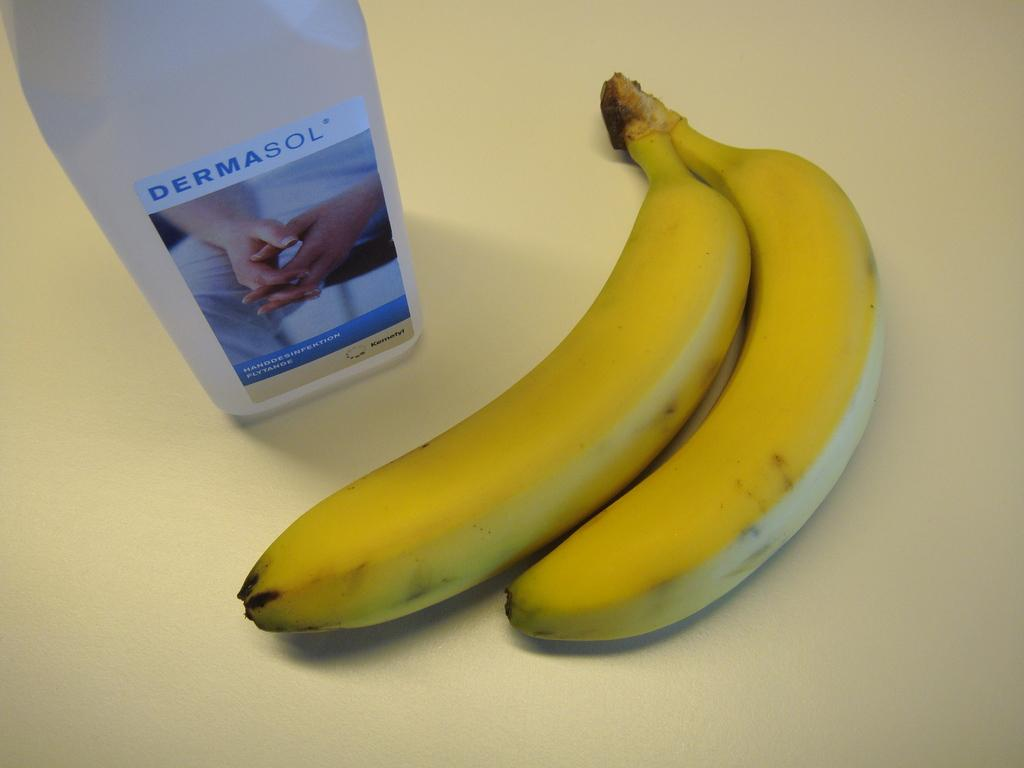What is the main subject in the center of the image? There are bananas in the center of the image. What other object can be seen on the table? There is a bottle on the table. What type of police officer is standing next to the bananas in the image? There are no police officers present in the image; it only features bananas and a bottle on the table. 